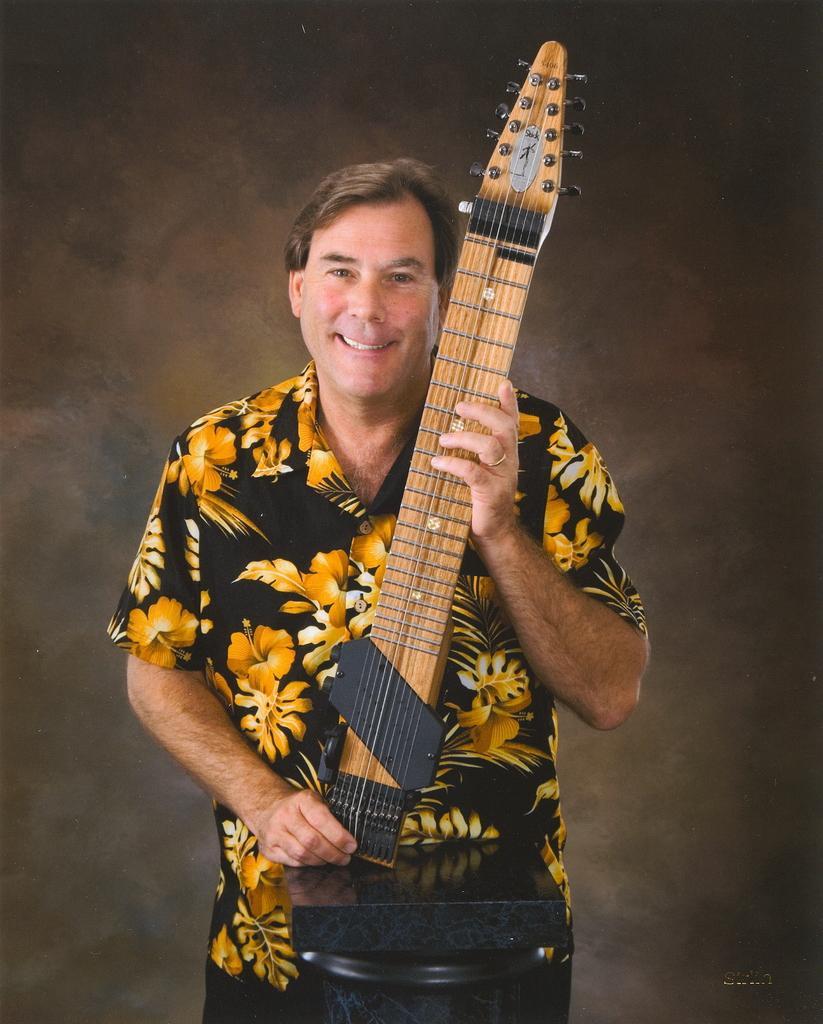In one or two sentences, can you explain what this image depicts? In this picture we can see a man standing and he is smiling. He wore floral printed shirt. We can see he is holding a musical instrument in his hand and this is a ring on his finger. 